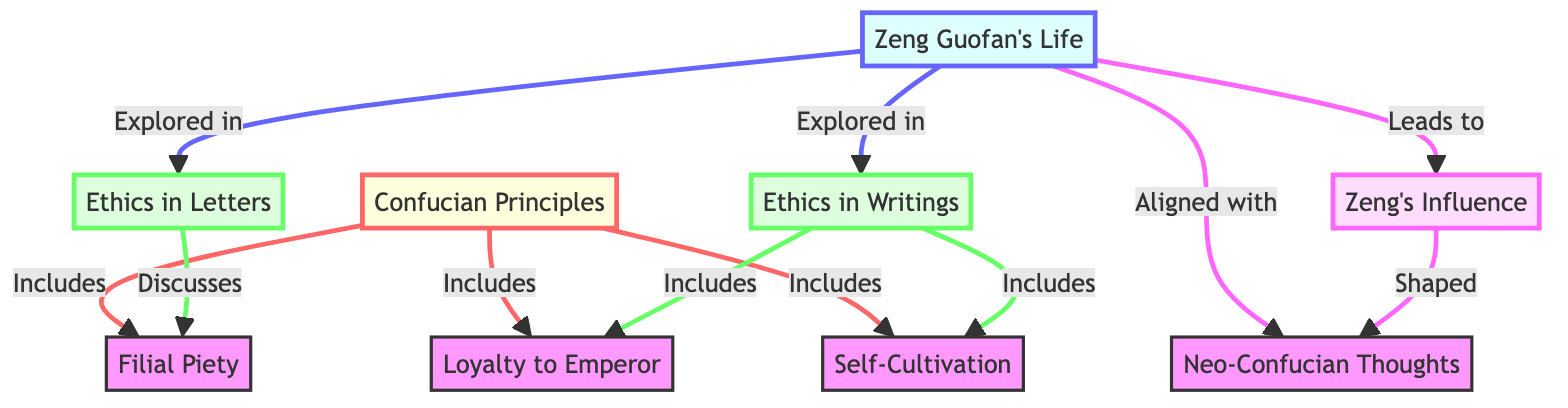What are the three main components included in Confucian Principles? The diagram indicates that Confucian Principles include Filial Piety, Loyalty to Emperor, and Self-Cultivation, as these are directly connected to the Confucian Principles node.
Answer: Filial Piety, Loyalty to Emperor, Self-Cultivation How many nodes represent Zeng Guofan's Life related concepts in the diagram? The diagram shows two nodes directly related to Zeng Guofan's Life, which are Ethics in Letters and Ethics in Writings.
Answer: 2 Which Confucian concept is discussed in Ethics in Letters? The diagram explicitly indicates that Ethics in Letters discusses Filial Piety, as it is directly linked to that node.
Answer: Filial Piety How does Zeng Guofan's Life influence Neo-Confucian Thoughts according to the diagram? The flowchart shows that Zeng Guofan's Life aligns with Neo-Confucian Thoughts and leads to Zeng's Influence, indicating that his life experiences played a significant role in shaping these thoughts.
Answer: Aligned and Leads to What is the relationship between Ethics in Writings and Loyalty to Emperor? The diagram illustrates that Ethics in Writings includes Loyalty to Emperor, meaning that the writings of Zeng Guofan encompass this principle as a part of the ethical discussion.
Answer: Includes What is the overall theme represented by the nodes connected to Zeng's Influence? The diagram shows that Zeng's Influence is shaped by Zeng Guofan's Life and might also suggest a broader impact on Neo-Confucian Thoughts, thus the theme centers on the intersection of personal experiences and philosophical development.
Answer: Shaped What type of ethical concepts are explored in both Ethics in Letters and Ethics in Writings? Both nodes represent ethical concepts derived from Confucian Principles; Ethics in Letters discusses Filial Piety, while Ethics in Writings covers Loyalty to Emperor and Self-Cultivation, showcasing a diverse exploration of ethics.
Answer: Ethical concepts What are the two key concepts included in Ethics in Writings? The diagram directly states that Ethics in Writings includes Loyalty to Emperor and Self-Cultivation, providing clear information on what these writings address.
Answer: Loyalty to Emperor, Self-Cultivation How many relationships does the node Confucian Principles have? The diagram shows three distinct relationships connecting Confucian Principles to Filial Piety, Loyalty to Emperor, and Self-Cultivation, indicating the breadth of this principle.
Answer: 3 